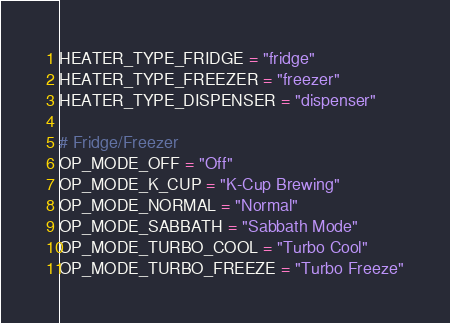Convert code to text. <code><loc_0><loc_0><loc_500><loc_500><_Python_>HEATER_TYPE_FRIDGE = "fridge"
HEATER_TYPE_FREEZER = "freezer"
HEATER_TYPE_DISPENSER = "dispenser"

# Fridge/Freezer
OP_MODE_OFF = "Off"
OP_MODE_K_CUP = "K-Cup Brewing"
OP_MODE_NORMAL = "Normal"
OP_MODE_SABBATH = "Sabbath Mode"
OP_MODE_TURBO_COOL = "Turbo Cool"
OP_MODE_TURBO_FREEZE = "Turbo Freeze"
</code> 